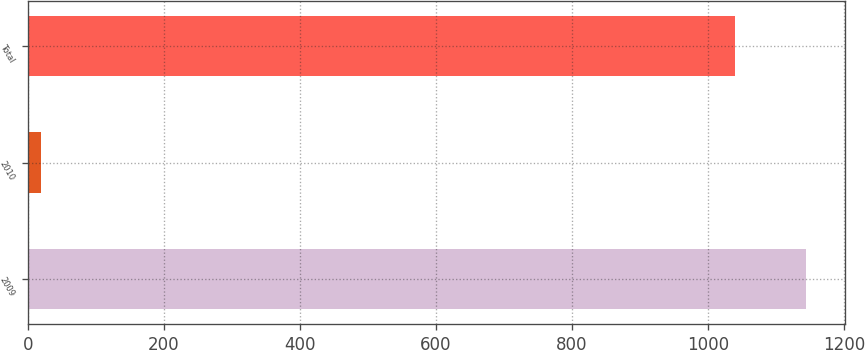Convert chart. <chart><loc_0><loc_0><loc_500><loc_500><bar_chart><fcel>2009<fcel>2010<fcel>Total<nl><fcel>1144<fcel>19<fcel>1040<nl></chart> 